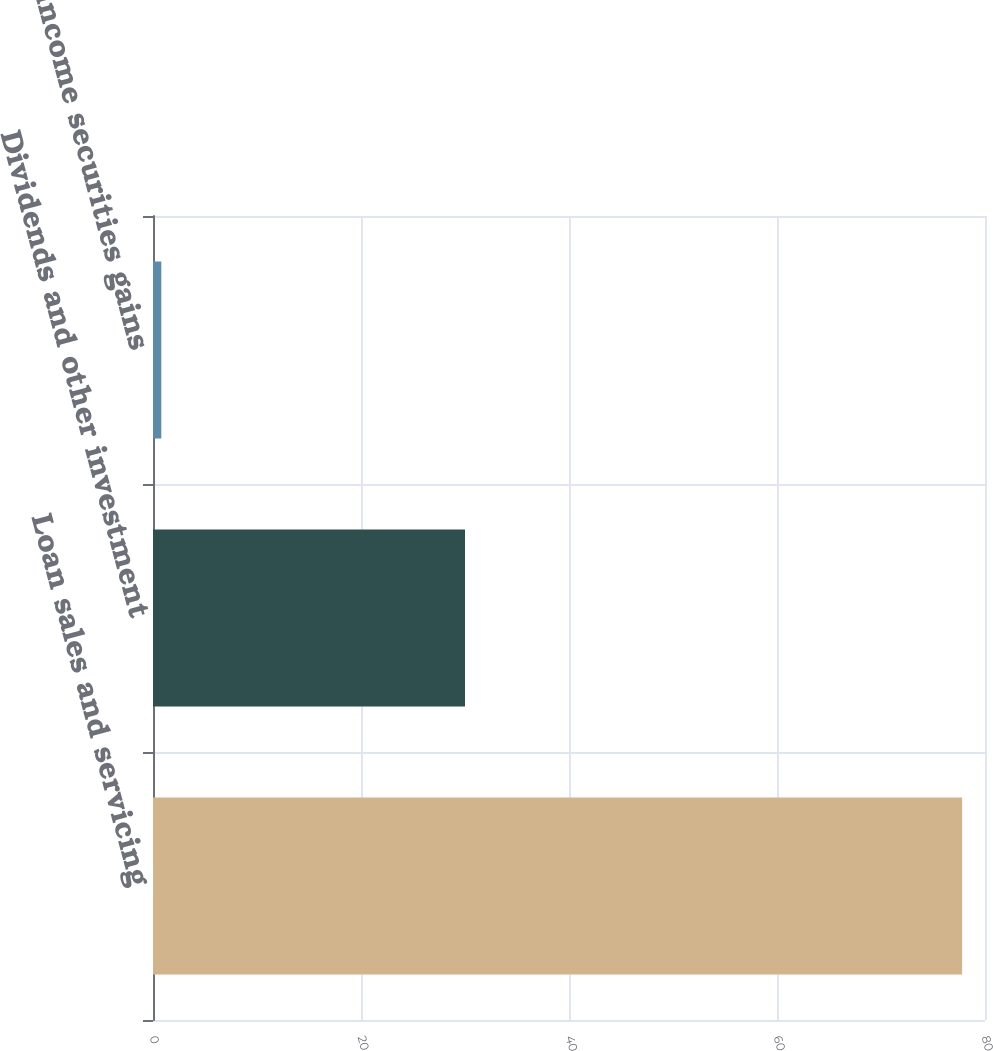Convert chart to OTSL. <chart><loc_0><loc_0><loc_500><loc_500><bar_chart><fcel>Loan sales and servicing<fcel>Dividends and other investment<fcel>Fixed income securities gains<nl><fcel>77.8<fcel>30<fcel>0.8<nl></chart> 